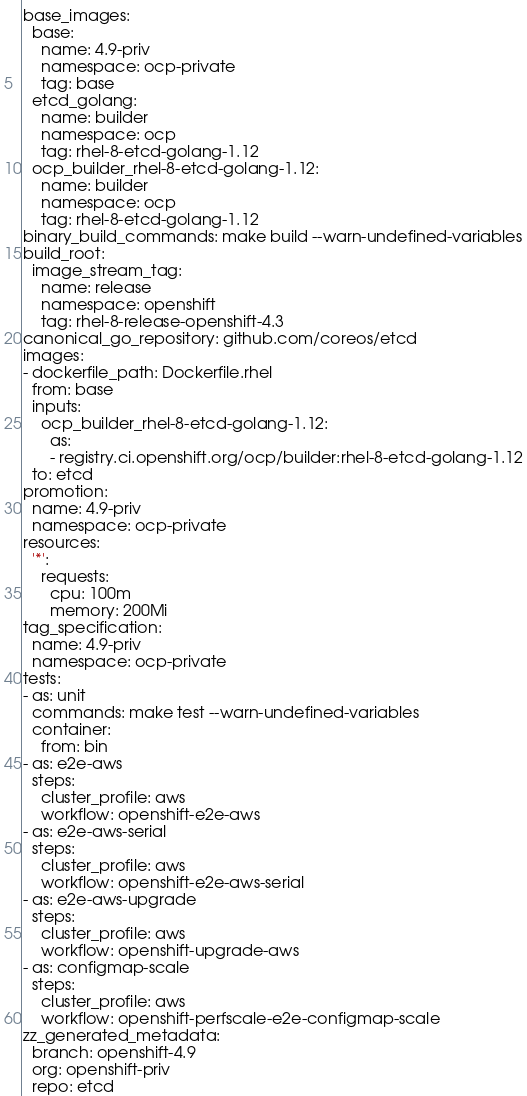Convert code to text. <code><loc_0><loc_0><loc_500><loc_500><_YAML_>base_images:
  base:
    name: 4.9-priv
    namespace: ocp-private
    tag: base
  etcd_golang:
    name: builder
    namespace: ocp
    tag: rhel-8-etcd-golang-1.12
  ocp_builder_rhel-8-etcd-golang-1.12:
    name: builder
    namespace: ocp
    tag: rhel-8-etcd-golang-1.12
binary_build_commands: make build --warn-undefined-variables
build_root:
  image_stream_tag:
    name: release
    namespace: openshift
    tag: rhel-8-release-openshift-4.3
canonical_go_repository: github.com/coreos/etcd
images:
- dockerfile_path: Dockerfile.rhel
  from: base
  inputs:
    ocp_builder_rhel-8-etcd-golang-1.12:
      as:
      - registry.ci.openshift.org/ocp/builder:rhel-8-etcd-golang-1.12
  to: etcd
promotion:
  name: 4.9-priv
  namespace: ocp-private
resources:
  '*':
    requests:
      cpu: 100m
      memory: 200Mi
tag_specification:
  name: 4.9-priv
  namespace: ocp-private
tests:
- as: unit
  commands: make test --warn-undefined-variables
  container:
    from: bin
- as: e2e-aws
  steps:
    cluster_profile: aws
    workflow: openshift-e2e-aws
- as: e2e-aws-serial
  steps:
    cluster_profile: aws
    workflow: openshift-e2e-aws-serial
- as: e2e-aws-upgrade
  steps:
    cluster_profile: aws
    workflow: openshift-upgrade-aws
- as: configmap-scale
  steps:
    cluster_profile: aws
    workflow: openshift-perfscale-e2e-configmap-scale
zz_generated_metadata:
  branch: openshift-4.9
  org: openshift-priv
  repo: etcd
</code> 